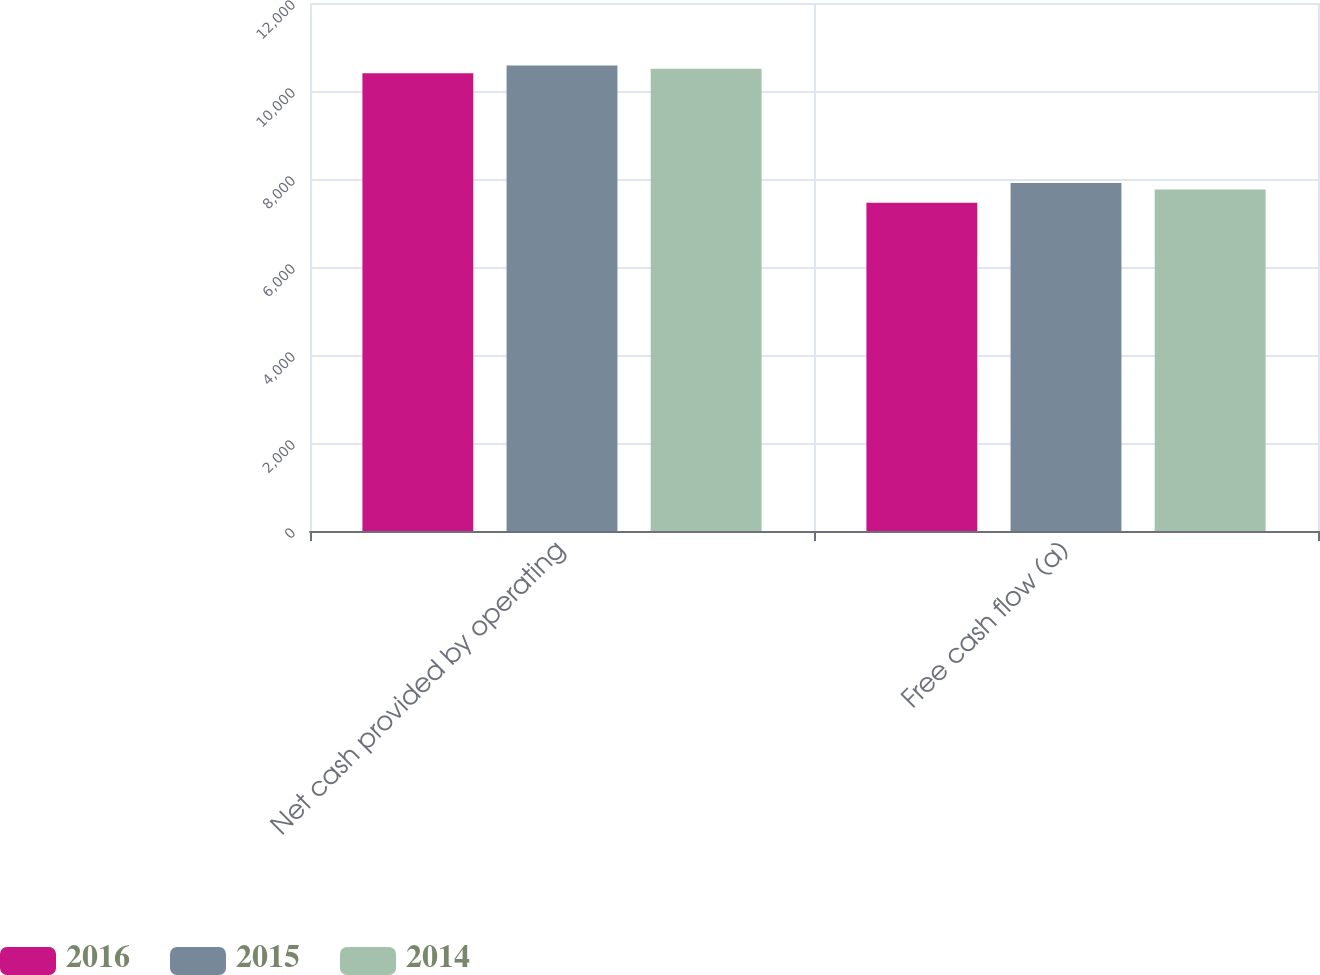<chart> <loc_0><loc_0><loc_500><loc_500><stacked_bar_chart><ecel><fcel>Net cash provided by operating<fcel>Free cash flow (a)<nl><fcel>2016<fcel>10404<fcel>7463<nl><fcel>2015<fcel>10580<fcel>7908<nl><fcel>2014<fcel>10506<fcel>7762<nl></chart> 